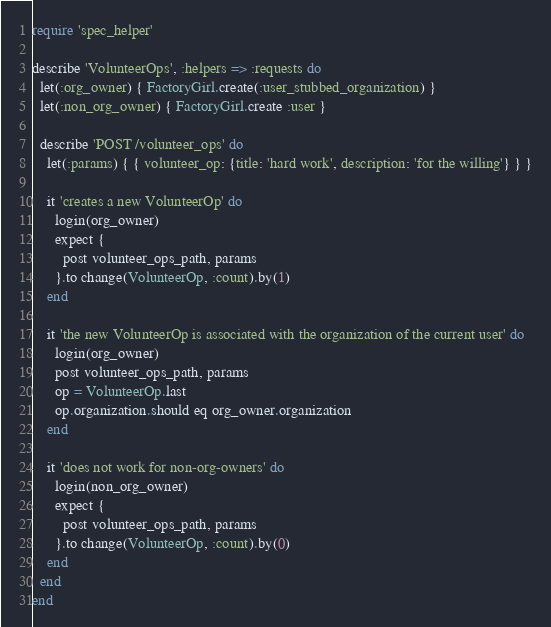Convert code to text. <code><loc_0><loc_0><loc_500><loc_500><_Ruby_>require 'spec_helper'

describe 'VolunteerOps', :helpers => :requests do
  let(:org_owner) { FactoryGirl.create(:user_stubbed_organization) }
  let(:non_org_owner) { FactoryGirl.create :user }

  describe 'POST /volunteer_ops' do
    let(:params) { { volunteer_op: {title: 'hard work', description: 'for the willing'} } }

    it 'creates a new VolunteerOp' do
      login(org_owner)
      expect {
        post volunteer_ops_path, params
      }.to change(VolunteerOp, :count).by(1)
    end

    it 'the new VolunteerOp is associated with the organization of the current user' do
      login(org_owner)
      post volunteer_ops_path, params
      op = VolunteerOp.last
      op.organization.should eq org_owner.organization
    end

    it 'does not work for non-org-owners' do
      login(non_org_owner)
      expect {
        post volunteer_ops_path, params
      }.to change(VolunteerOp, :count).by(0)
    end
  end
end
</code> 